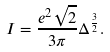<formula> <loc_0><loc_0><loc_500><loc_500>I = \frac { e ^ { 2 } \sqrt { 2 } } { 3 \pi } \Delta ^ { \frac { 3 } { 2 } } .</formula> 